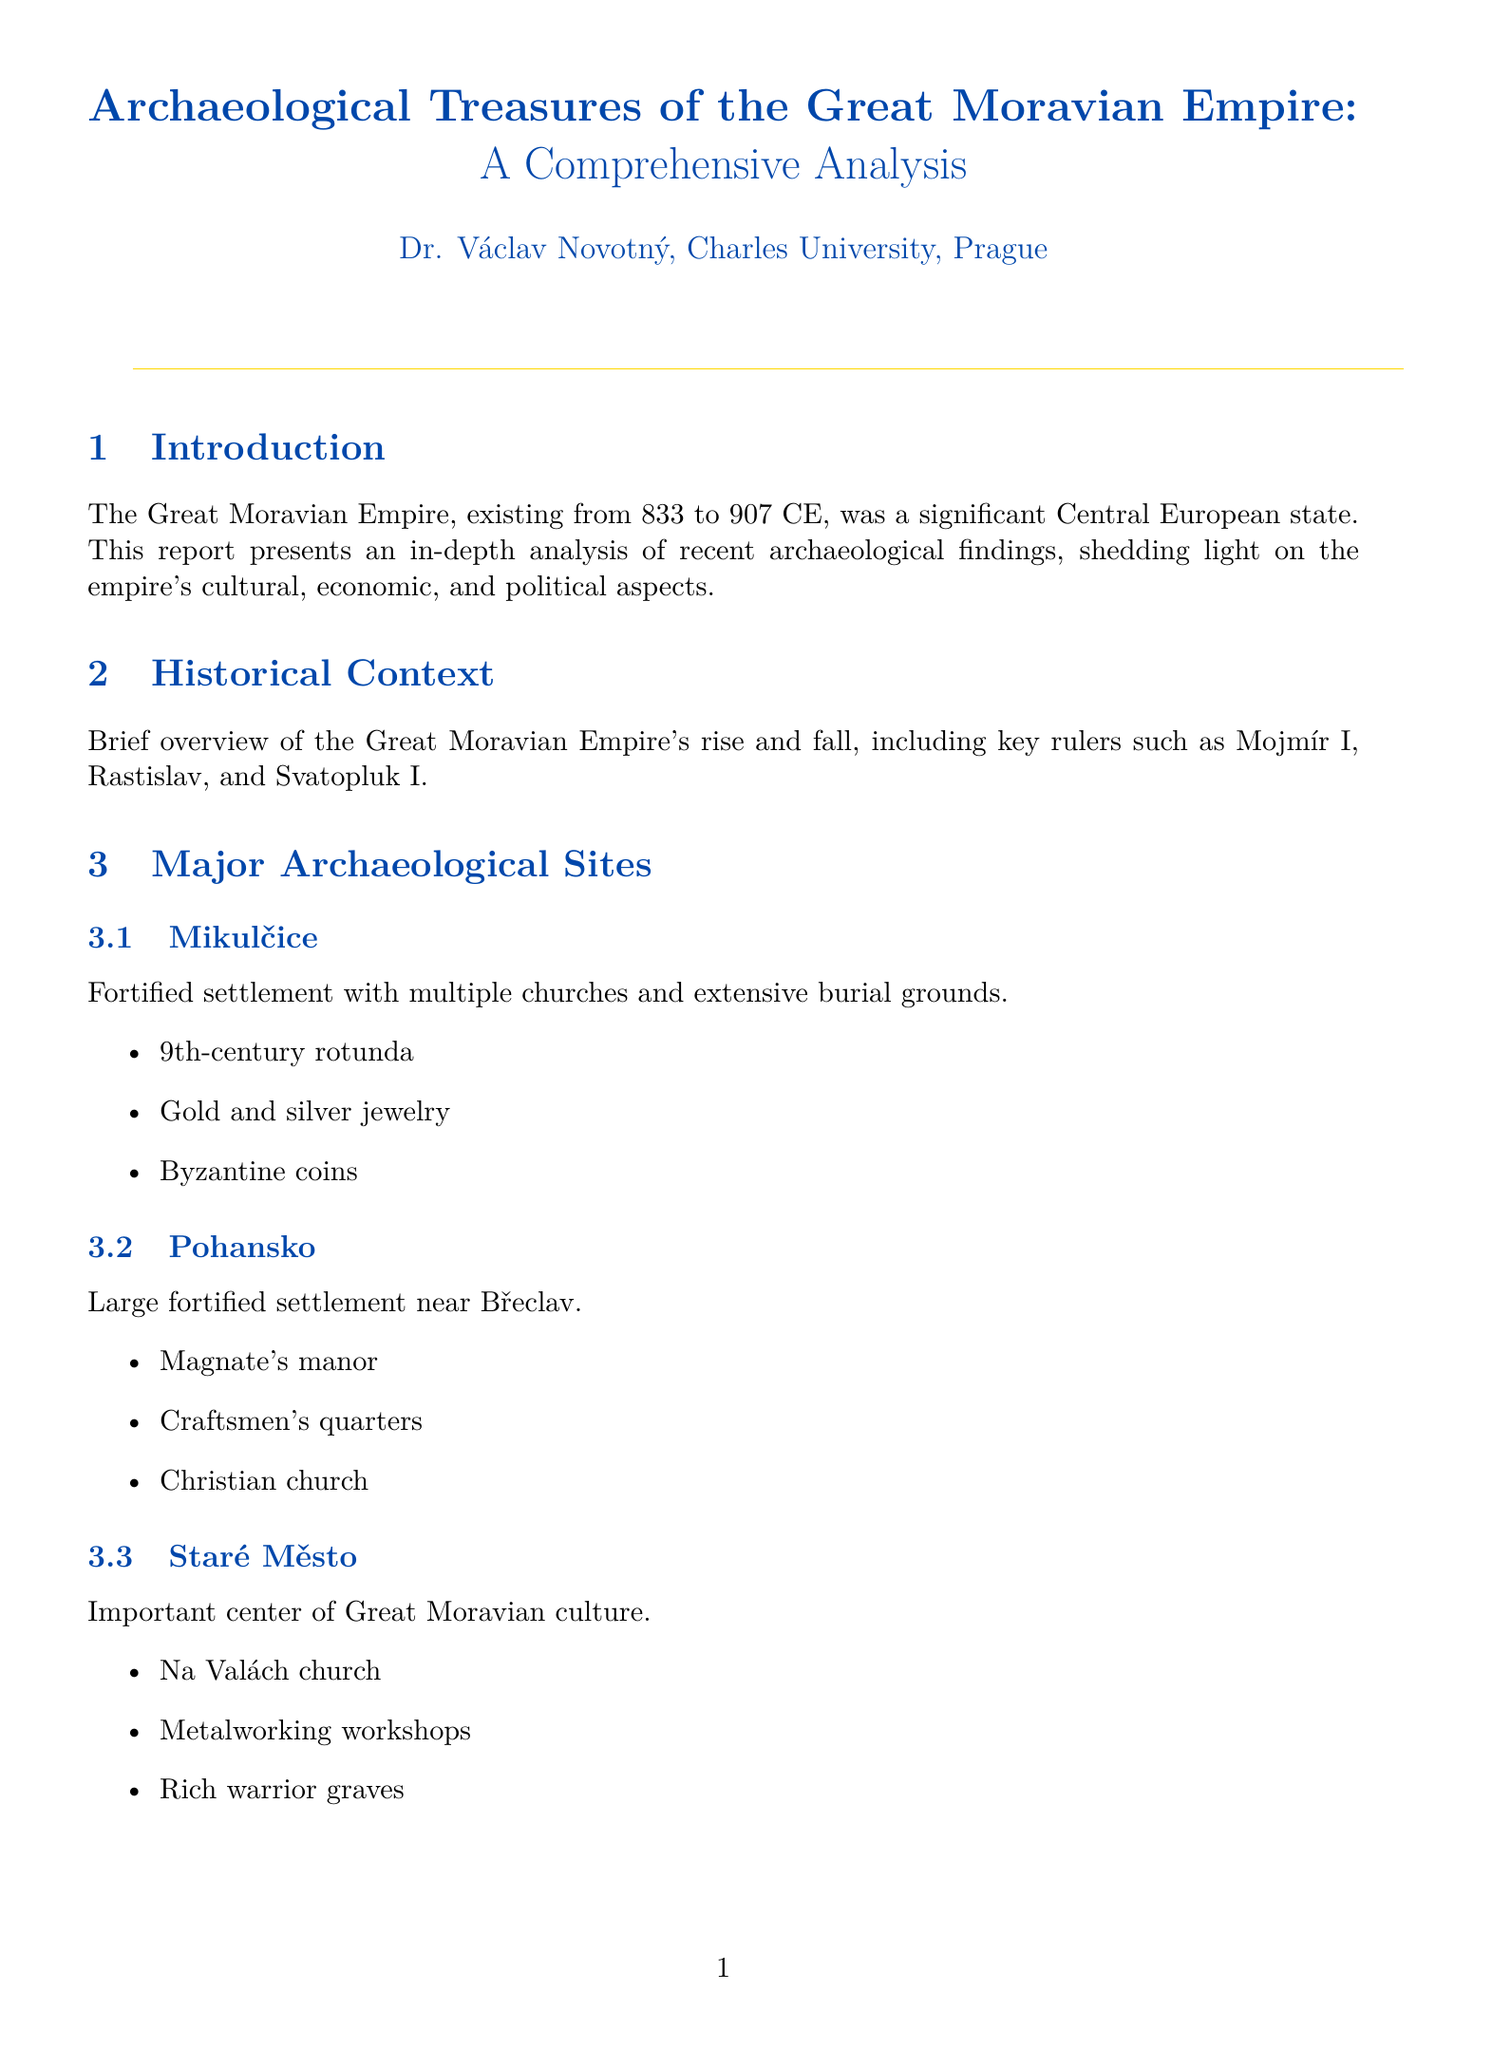What is the title of the report? The title of the report indicates its content and focus, which is presented in the document.
Answer: Archaeological Treasures of the Great Moravian Empire: A Comprehensive Analysis Who is the author of the report? The author is credited with the research and writing of the report, as stated in the document.
Answer: Dr. Václav Novotný, Charles University, Prague What is the time period of the Great Moravian Empire? The time period mentioned in the introduction gives the historical context of the empire's existence.
Answer: 833 to 907 CE Which archaeological site included a 9th-century rotunda? This question asks for a specific finding related to one of the archaeological sites mentioned.
Answer: Mikulčice What types of items are categorized under Weapons in the Artifact Catalogue? This question seeks to identify the specific items listed in the weapons category.
Answer: Carolingian swords, Battle axes, Spearheads What significant analysis is conducted in the Economic Insights section? The Economic Insights section covers specific areas of interest based on the findings.
Answer: Analysis of trade routes, local craftsmanship, and agricultural practices How many maps are included in the report? This question asks for a counting of the maps in the document.
Answer: Three What influences are discussed in relation to Great Moravian material culture? This question prompts a synthesis of cultural influences mentioned in the document.
Answer: Slavic, Frankish, and Byzantine influences Which church is associated with the archaeological site Staré Město? This question asks for a specific finding related to the Staré Město site.
Answer: Na Valách church 